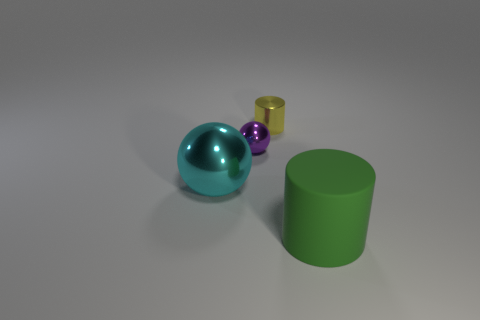The tiny purple thing that is made of the same material as the cyan thing is what shape?
Give a very brief answer. Sphere. There is a object that is in front of the small purple metal thing and to the left of the yellow object; what color is it?
Make the answer very short. Cyan. Is the ball that is on the left side of the purple metal sphere made of the same material as the tiny purple sphere?
Your answer should be very brief. Yes. Is the number of large green objects on the left side of the tiny yellow thing less than the number of blue shiny blocks?
Offer a very short reply. No. Is there a cyan ball made of the same material as the small yellow cylinder?
Offer a terse response. Yes. There is a cyan shiny sphere; does it have the same size as the cylinder that is on the right side of the yellow object?
Make the answer very short. Yes. Does the large cyan ball have the same material as the small cylinder?
Provide a short and direct response. Yes. There is a small yellow metallic thing; how many green cylinders are right of it?
Provide a succinct answer. 1. There is a thing that is on the right side of the small purple object and in front of the shiny cylinder; what material is it made of?
Your answer should be compact. Rubber. How many spheres have the same size as the green rubber cylinder?
Ensure brevity in your answer.  1. 